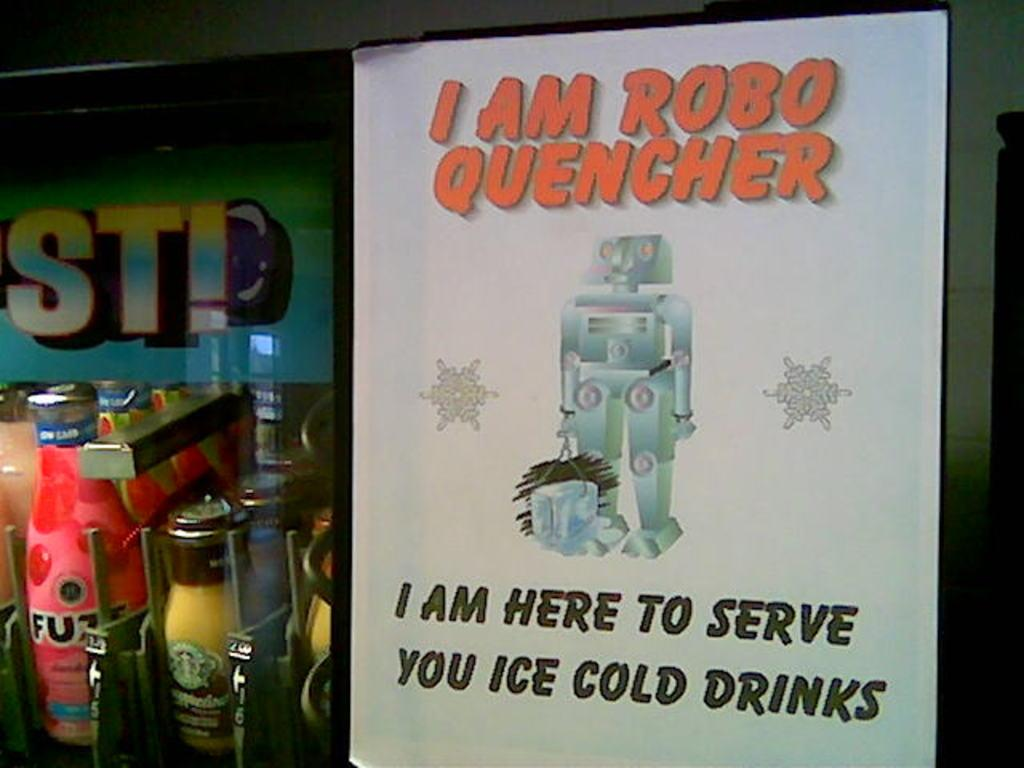<image>
Present a compact description of the photo's key features. a poster reading I am Robo Quencher for an automated drink server 